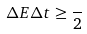<formula> <loc_0><loc_0><loc_500><loc_500>\Delta E \Delta t \geq \frac { } { 2 }</formula> 